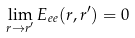<formula> <loc_0><loc_0><loc_500><loc_500>\lim _ { { r } \to { r ^ { \prime } } } E _ { e e } ( { r } , { r ^ { \prime } } ) = 0</formula> 